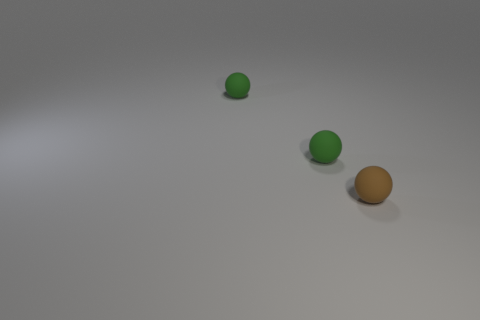How many objects are tiny rubber balls behind the brown ball or green balls?
Your answer should be very brief. 2. Is there any other thing that has the same material as the small brown sphere?
Give a very brief answer. Yes. Is the number of tiny brown objects that are to the right of the brown rubber sphere less than the number of balls?
Your response must be concise. Yes. What number of green spheres have the same material as the small brown ball?
Keep it short and to the point. 2. Are there an equal number of matte spheres that are behind the tiny brown object and green balls?
Keep it short and to the point. Yes. Is there another brown rubber ball that has the same size as the brown sphere?
Provide a short and direct response. No. How many other objects are the same shape as the tiny brown matte object?
Provide a short and direct response. 2. What number of big things are purple shiny spheres or brown objects?
Give a very brief answer. 0. How many rubber things are small objects or green objects?
Ensure brevity in your answer.  3. What number of green things are rubber spheres or tiny metal spheres?
Offer a terse response. 2. 